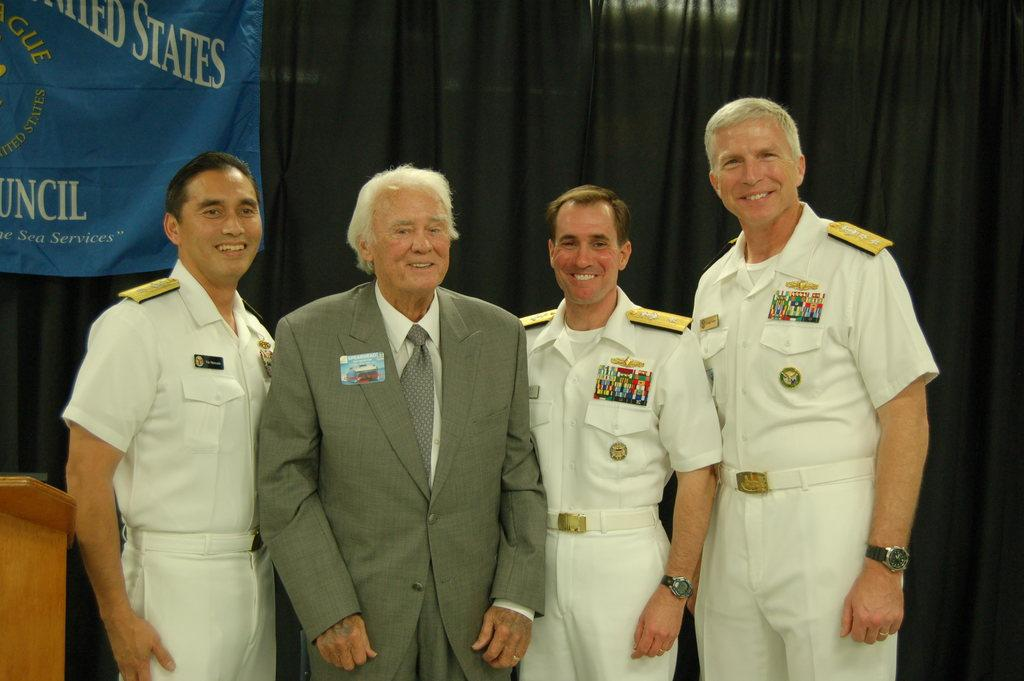Provide a one-sentence caption for the provided image. Four men pose for a photo in front of a blue banner that has the word "states" on it. 